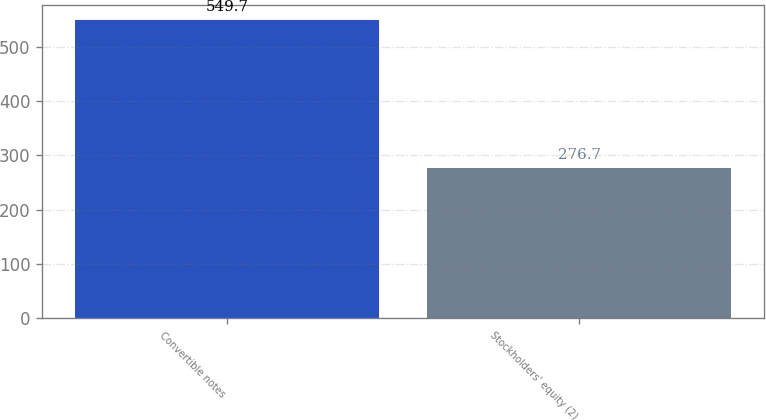Convert chart to OTSL. <chart><loc_0><loc_0><loc_500><loc_500><bar_chart><fcel>Convertible notes<fcel>Stockholders' equity (2)<nl><fcel>549.7<fcel>276.7<nl></chart> 